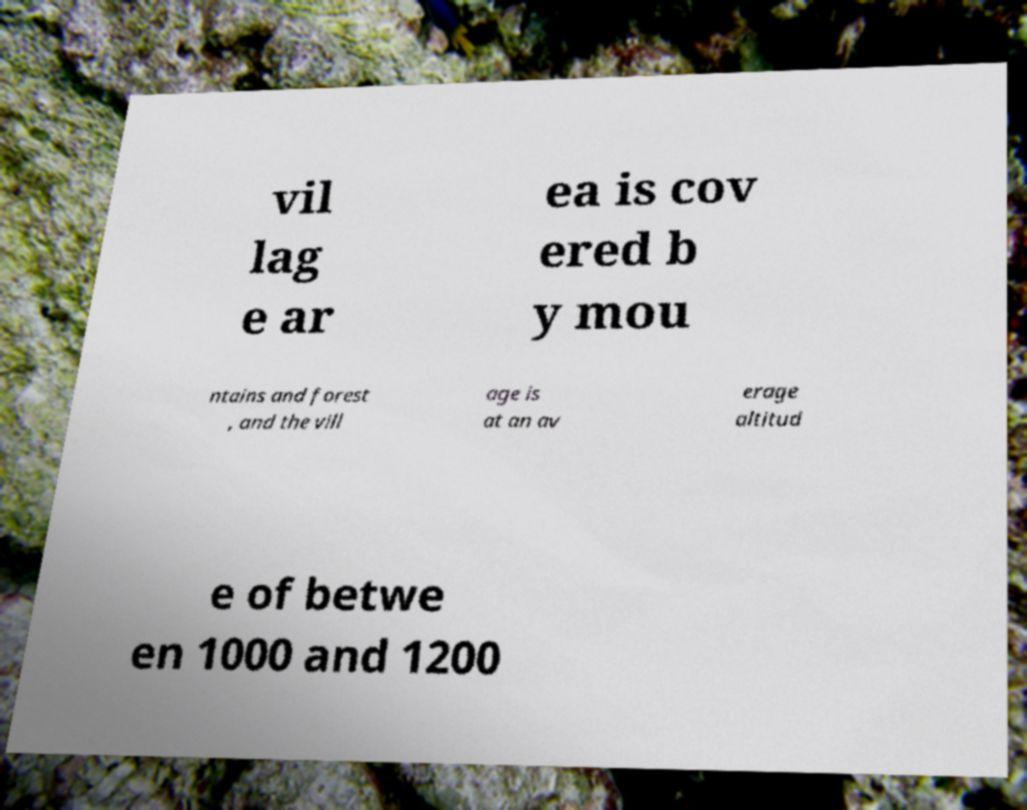What messages or text are displayed in this image? I need them in a readable, typed format. vil lag e ar ea is cov ered b y mou ntains and forest , and the vill age is at an av erage altitud e of betwe en 1000 and 1200 